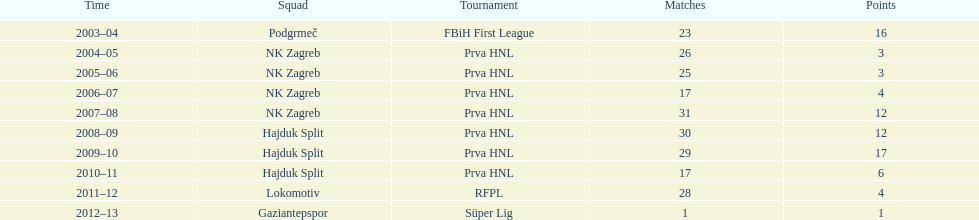After scoring against bulgaria in zenica, ibricic also scored against this team in a 7-0 victory in zenica less then a month after the friendly match against bulgaria. Estonia. 